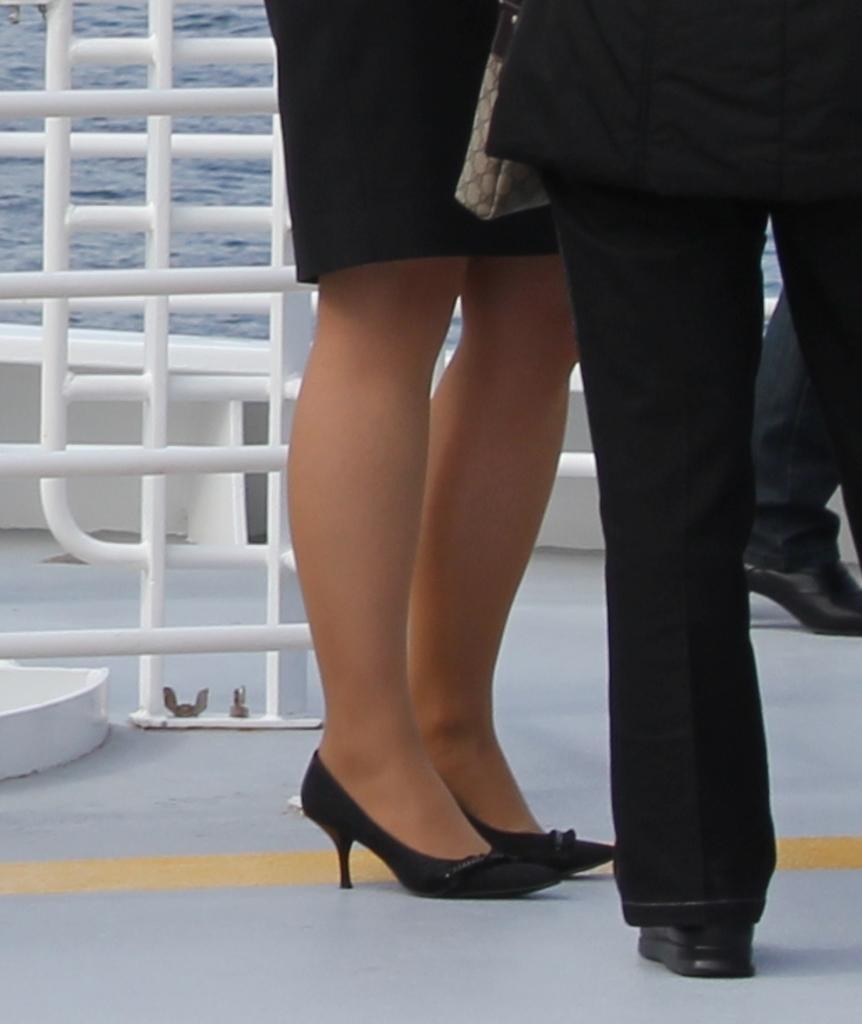In one or two sentences, can you explain what this image depicts? In this image we can see legs of a woman and a man standing on the floor. On the backside we can see some poles and the water. 